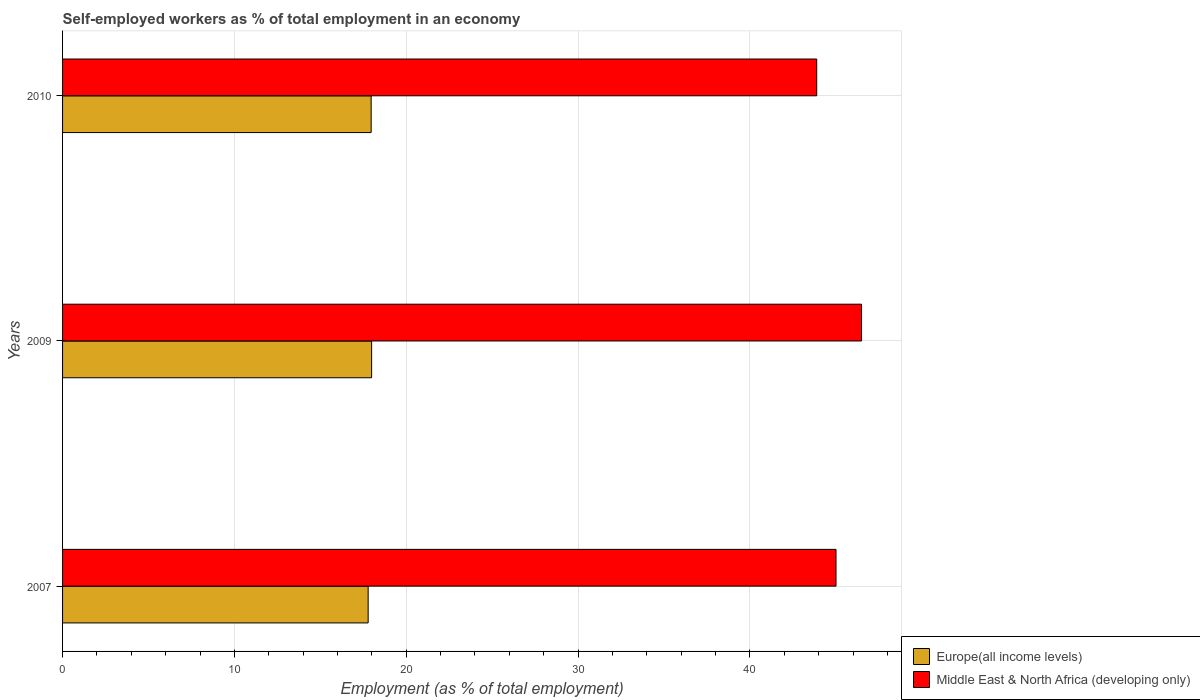How many different coloured bars are there?
Offer a very short reply. 2. How many groups of bars are there?
Ensure brevity in your answer.  3. Are the number of bars on each tick of the Y-axis equal?
Give a very brief answer. Yes. How many bars are there on the 3rd tick from the top?
Offer a terse response. 2. What is the label of the 2nd group of bars from the top?
Offer a very short reply. 2009. What is the percentage of self-employed workers in Europe(all income levels) in 2009?
Keep it short and to the point. 17.99. Across all years, what is the maximum percentage of self-employed workers in Middle East & North Africa (developing only)?
Make the answer very short. 46.5. Across all years, what is the minimum percentage of self-employed workers in Middle East & North Africa (developing only)?
Your answer should be very brief. 43.89. What is the total percentage of self-employed workers in Middle East & North Africa (developing only) in the graph?
Offer a terse response. 135.4. What is the difference between the percentage of self-employed workers in Europe(all income levels) in 2007 and that in 2010?
Your answer should be very brief. -0.18. What is the difference between the percentage of self-employed workers in Europe(all income levels) in 2010 and the percentage of self-employed workers in Middle East & North Africa (developing only) in 2007?
Your answer should be very brief. -27.05. What is the average percentage of self-employed workers in Europe(all income levels) per year?
Ensure brevity in your answer.  17.91. In the year 2010, what is the difference between the percentage of self-employed workers in Europe(all income levels) and percentage of self-employed workers in Middle East & North Africa (developing only)?
Give a very brief answer. -25.93. What is the ratio of the percentage of self-employed workers in Europe(all income levels) in 2007 to that in 2009?
Provide a short and direct response. 0.99. Is the percentage of self-employed workers in Europe(all income levels) in 2009 less than that in 2010?
Offer a very short reply. No. Is the difference between the percentage of self-employed workers in Europe(all income levels) in 2009 and 2010 greater than the difference between the percentage of self-employed workers in Middle East & North Africa (developing only) in 2009 and 2010?
Make the answer very short. No. What is the difference between the highest and the second highest percentage of self-employed workers in Europe(all income levels)?
Your answer should be very brief. 0.03. What is the difference between the highest and the lowest percentage of self-employed workers in Middle East & North Africa (developing only)?
Keep it short and to the point. 2.61. What does the 2nd bar from the top in 2009 represents?
Your answer should be compact. Europe(all income levels). What does the 2nd bar from the bottom in 2009 represents?
Your answer should be compact. Middle East & North Africa (developing only). What is the difference between two consecutive major ticks on the X-axis?
Give a very brief answer. 10. Are the values on the major ticks of X-axis written in scientific E-notation?
Your answer should be very brief. No. Does the graph contain any zero values?
Provide a succinct answer. No. Does the graph contain grids?
Your response must be concise. Yes. How are the legend labels stacked?
Provide a short and direct response. Vertical. What is the title of the graph?
Ensure brevity in your answer.  Self-employed workers as % of total employment in an economy. What is the label or title of the X-axis?
Offer a terse response. Employment (as % of total employment). What is the Employment (as % of total employment) of Europe(all income levels) in 2007?
Your answer should be very brief. 17.78. What is the Employment (as % of total employment) of Middle East & North Africa (developing only) in 2007?
Your answer should be compact. 45.01. What is the Employment (as % of total employment) in Europe(all income levels) in 2009?
Provide a succinct answer. 17.99. What is the Employment (as % of total employment) in Middle East & North Africa (developing only) in 2009?
Your answer should be very brief. 46.5. What is the Employment (as % of total employment) in Europe(all income levels) in 2010?
Your response must be concise. 17.96. What is the Employment (as % of total employment) in Middle East & North Africa (developing only) in 2010?
Offer a terse response. 43.89. Across all years, what is the maximum Employment (as % of total employment) in Europe(all income levels)?
Offer a very short reply. 17.99. Across all years, what is the maximum Employment (as % of total employment) of Middle East & North Africa (developing only)?
Ensure brevity in your answer.  46.5. Across all years, what is the minimum Employment (as % of total employment) in Europe(all income levels)?
Keep it short and to the point. 17.78. Across all years, what is the minimum Employment (as % of total employment) of Middle East & North Africa (developing only)?
Offer a very short reply. 43.89. What is the total Employment (as % of total employment) in Europe(all income levels) in the graph?
Offer a very short reply. 53.73. What is the total Employment (as % of total employment) in Middle East & North Africa (developing only) in the graph?
Offer a very short reply. 135.4. What is the difference between the Employment (as % of total employment) in Europe(all income levels) in 2007 and that in 2009?
Your response must be concise. -0.2. What is the difference between the Employment (as % of total employment) of Middle East & North Africa (developing only) in 2007 and that in 2009?
Provide a succinct answer. -1.49. What is the difference between the Employment (as % of total employment) in Europe(all income levels) in 2007 and that in 2010?
Offer a terse response. -0.17. What is the difference between the Employment (as % of total employment) in Middle East & North Africa (developing only) in 2007 and that in 2010?
Provide a succinct answer. 1.12. What is the difference between the Employment (as % of total employment) of Europe(all income levels) in 2009 and that in 2010?
Offer a terse response. 0.03. What is the difference between the Employment (as % of total employment) in Middle East & North Africa (developing only) in 2009 and that in 2010?
Give a very brief answer. 2.61. What is the difference between the Employment (as % of total employment) of Europe(all income levels) in 2007 and the Employment (as % of total employment) of Middle East & North Africa (developing only) in 2009?
Offer a terse response. -28.71. What is the difference between the Employment (as % of total employment) in Europe(all income levels) in 2007 and the Employment (as % of total employment) in Middle East & North Africa (developing only) in 2010?
Ensure brevity in your answer.  -26.1. What is the difference between the Employment (as % of total employment) of Europe(all income levels) in 2009 and the Employment (as % of total employment) of Middle East & North Africa (developing only) in 2010?
Offer a terse response. -25.9. What is the average Employment (as % of total employment) of Europe(all income levels) per year?
Your answer should be very brief. 17.91. What is the average Employment (as % of total employment) of Middle East & North Africa (developing only) per year?
Your answer should be compact. 45.13. In the year 2007, what is the difference between the Employment (as % of total employment) of Europe(all income levels) and Employment (as % of total employment) of Middle East & North Africa (developing only)?
Give a very brief answer. -27.23. In the year 2009, what is the difference between the Employment (as % of total employment) in Europe(all income levels) and Employment (as % of total employment) in Middle East & North Africa (developing only)?
Give a very brief answer. -28.51. In the year 2010, what is the difference between the Employment (as % of total employment) of Europe(all income levels) and Employment (as % of total employment) of Middle East & North Africa (developing only)?
Provide a succinct answer. -25.93. What is the ratio of the Employment (as % of total employment) of Middle East & North Africa (developing only) in 2007 to that in 2009?
Offer a very short reply. 0.97. What is the ratio of the Employment (as % of total employment) of Europe(all income levels) in 2007 to that in 2010?
Provide a succinct answer. 0.99. What is the ratio of the Employment (as % of total employment) in Middle East & North Africa (developing only) in 2007 to that in 2010?
Offer a terse response. 1.03. What is the ratio of the Employment (as % of total employment) in Europe(all income levels) in 2009 to that in 2010?
Give a very brief answer. 1. What is the ratio of the Employment (as % of total employment) in Middle East & North Africa (developing only) in 2009 to that in 2010?
Keep it short and to the point. 1.06. What is the difference between the highest and the second highest Employment (as % of total employment) of Europe(all income levels)?
Ensure brevity in your answer.  0.03. What is the difference between the highest and the second highest Employment (as % of total employment) of Middle East & North Africa (developing only)?
Give a very brief answer. 1.49. What is the difference between the highest and the lowest Employment (as % of total employment) of Europe(all income levels)?
Offer a terse response. 0.2. What is the difference between the highest and the lowest Employment (as % of total employment) of Middle East & North Africa (developing only)?
Give a very brief answer. 2.61. 